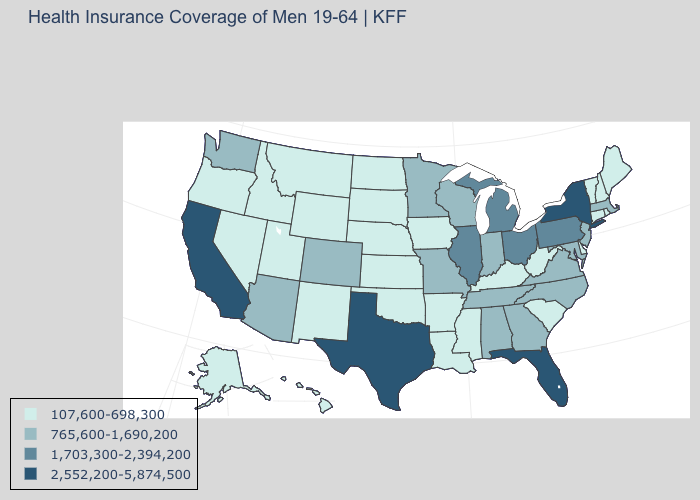Does Washington have the lowest value in the West?
Write a very short answer. No. What is the value of Hawaii?
Answer briefly. 107,600-698,300. Name the states that have a value in the range 107,600-698,300?
Answer briefly. Alaska, Arkansas, Connecticut, Delaware, Hawaii, Idaho, Iowa, Kansas, Kentucky, Louisiana, Maine, Mississippi, Montana, Nebraska, Nevada, New Hampshire, New Mexico, North Dakota, Oklahoma, Oregon, Rhode Island, South Carolina, South Dakota, Utah, Vermont, West Virginia, Wyoming. What is the lowest value in states that border Wisconsin?
Give a very brief answer. 107,600-698,300. How many symbols are there in the legend?
Answer briefly. 4. Does California have the highest value in the USA?
Quick response, please. Yes. Does Alaska have the lowest value in the West?
Concise answer only. Yes. What is the highest value in states that border Louisiana?
Keep it brief. 2,552,200-5,874,500. Among the states that border Colorado , does Wyoming have the lowest value?
Concise answer only. Yes. Name the states that have a value in the range 1,703,300-2,394,200?
Short answer required. Illinois, Michigan, Ohio, Pennsylvania. How many symbols are there in the legend?
Give a very brief answer. 4. Does Indiana have the highest value in the USA?
Give a very brief answer. No. Does the first symbol in the legend represent the smallest category?
Quick response, please. Yes. Name the states that have a value in the range 2,552,200-5,874,500?
Concise answer only. California, Florida, New York, Texas. What is the value of Alabama?
Quick response, please. 765,600-1,690,200. 